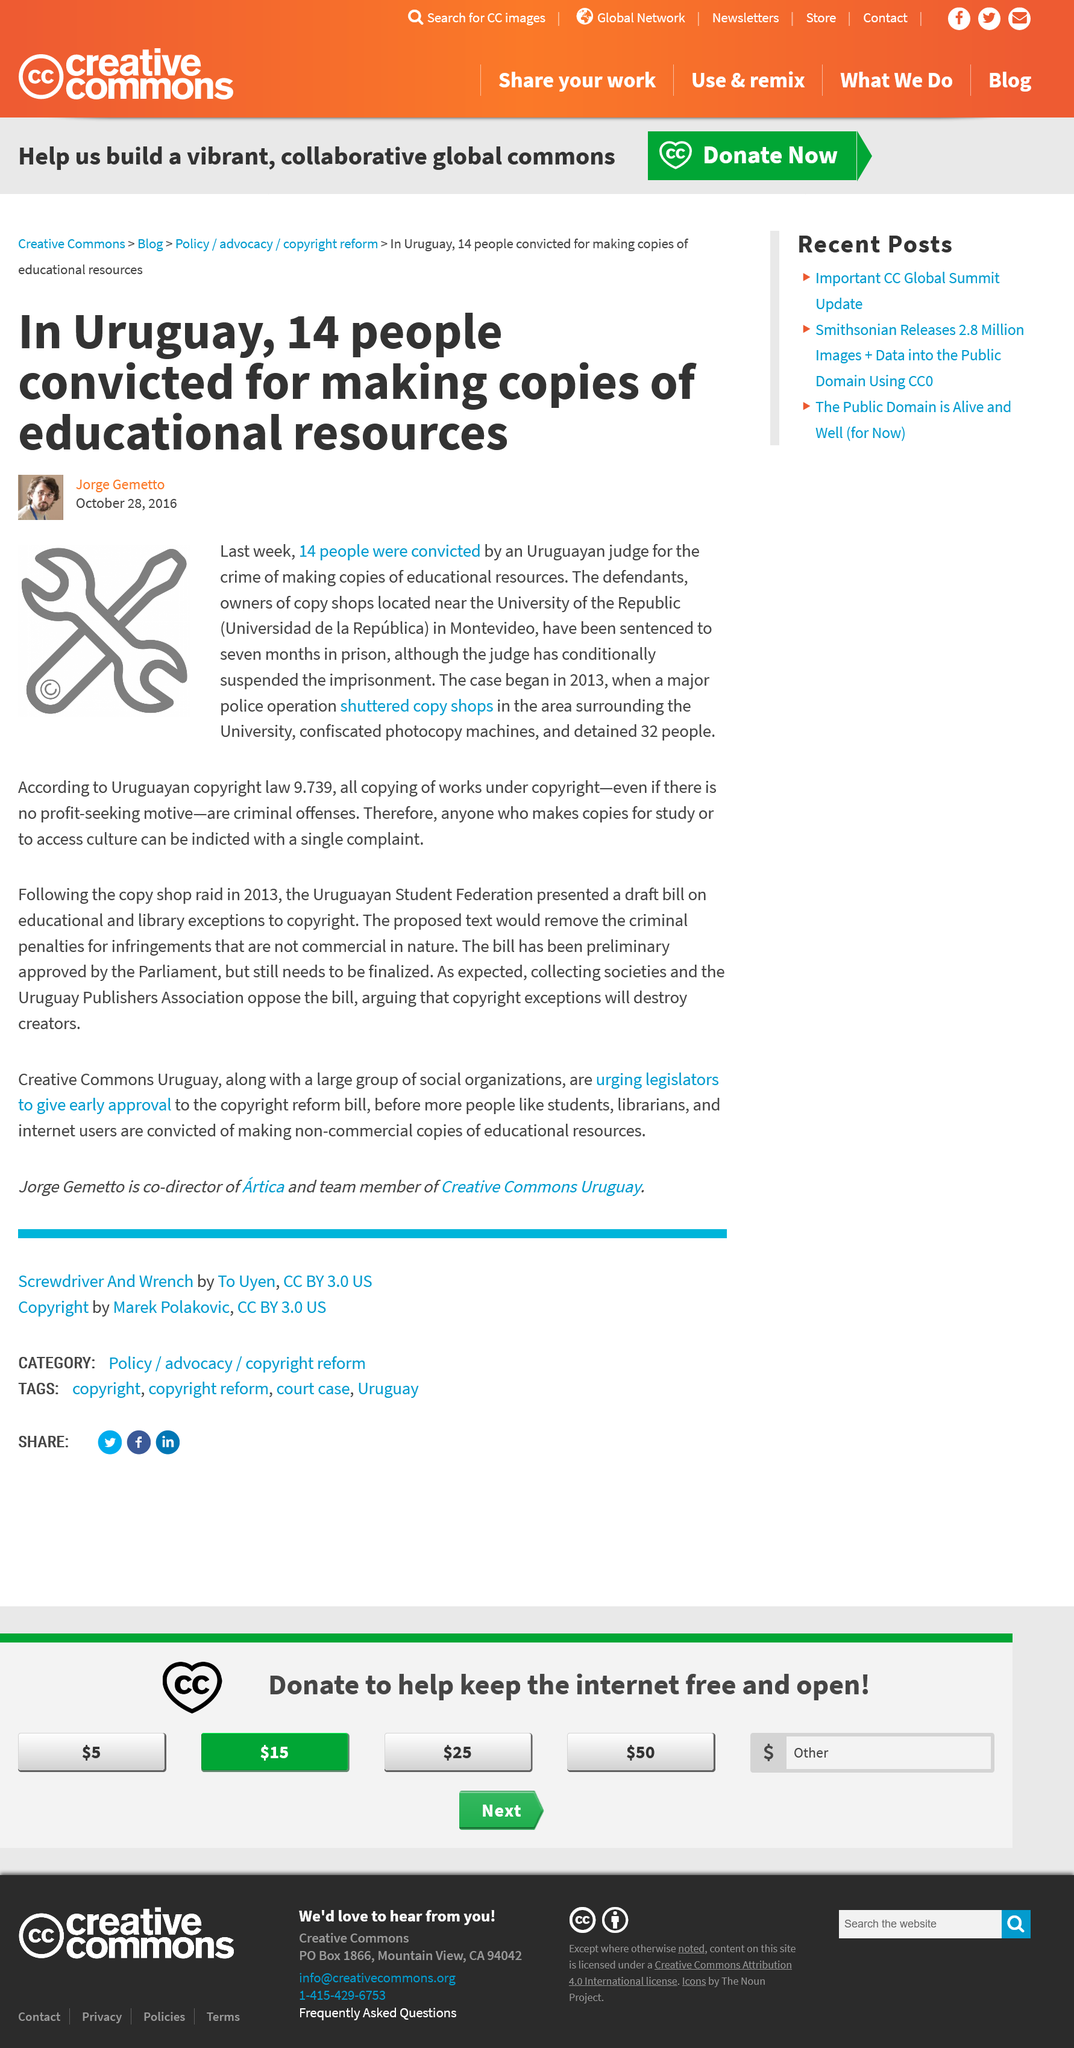Indicate a few pertinent items in this graphic. The individuals were sentenced to serve 7 months in prison. Fourteen individuals were convicted due to their actions of creating copies of educational resources. The case began in 2013. 